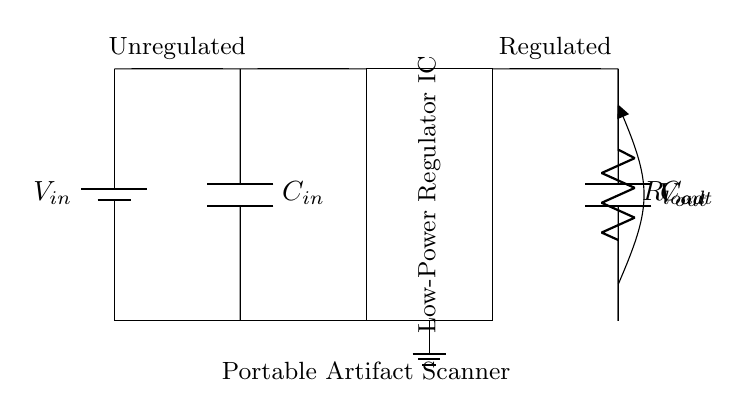What is the input voltage for this circuit? The input voltage is represented by the battery symbol labeled as V_in, which supplies the circuit with the necessary voltage.
Answer: V_in What type of device does this circuit power? The circuit diagram includes a label indicating that it's part of a Portable Artifact Scanner, which implies its purpose in powering this specific device.
Answer: Portable Artifact Scanner What are the values represented by C_in and C_out? C_in and C_out are capacitors indicated in the circuit, and although their values are not specified in the diagram, they serve to stabilize input and output voltages, respectively.
Answer: Capacitors How many resistors are in the circuit? The diagram shows a single resistor labeled as R_load connected in the output path of the voltage regulator circuit, which indicates the load the regulator must drive.
Answer: One What is the purpose of the voltage regulator IC? The voltage regulator IC's role is to ensure that the output voltage remains stable despite variations in input voltage or load conditions, indicated by its placement and label in the circuit.
Answer: Voltage regulation How is the output voltage obtained? The output voltage, labeled as V_out in the circuit, is derived from C_out and R_load, showing that the output is regulated and connected to the load from the regulator output.
Answer: Through C_out and R_load What is the significance of the ground connection in this circuit? The ground connection is crucial for establishing a common reference point for voltage levels in the circuit, ensuring safe operation and proper circuit function by completing the electrical loop.
Answer: Common reference point 